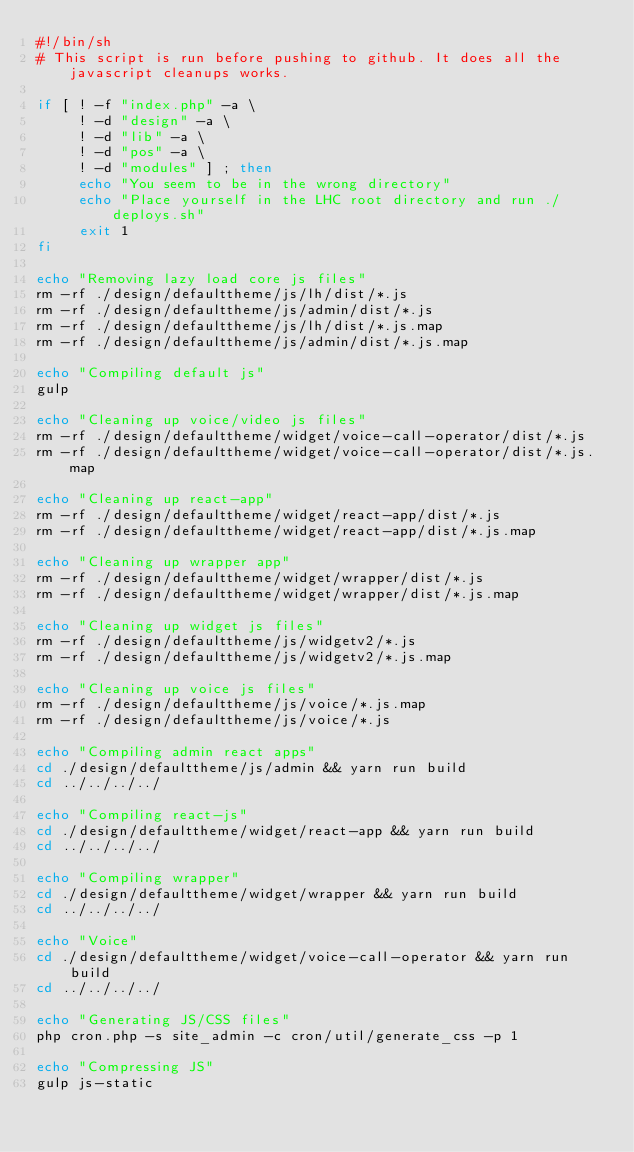Convert code to text. <code><loc_0><loc_0><loc_500><loc_500><_Bash_>#!/bin/sh
# This script is run before pushing to github. It does all the javascript cleanups works.

if [ ! -f "index.php" -a \
     ! -d "design" -a \
     ! -d "lib" -a \
     ! -d "pos" -a \
     ! -d "modules" ] ; then
     echo "You seem to be in the wrong directory"
     echo "Place yourself in the LHC root directory and run ./deploys.sh"
     exit 1
fi

echo "Removing lazy load core js files"
rm -rf ./design/defaulttheme/js/lh/dist/*.js
rm -rf ./design/defaulttheme/js/admin/dist/*.js
rm -rf ./design/defaulttheme/js/lh/dist/*.js.map
rm -rf ./design/defaulttheme/js/admin/dist/*.js.map

echo "Compiling default js"
gulp

echo "Cleaning up voice/video js files"
rm -rf ./design/defaulttheme/widget/voice-call-operator/dist/*.js
rm -rf ./design/defaulttheme/widget/voice-call-operator/dist/*.js.map

echo "Cleaning up react-app"
rm -rf ./design/defaulttheme/widget/react-app/dist/*.js
rm -rf ./design/defaulttheme/widget/react-app/dist/*.js.map

echo "Cleaning up wrapper app"
rm -rf ./design/defaulttheme/widget/wrapper/dist/*.js
rm -rf ./design/defaulttheme/widget/wrapper/dist/*.js.map

echo "Cleaning up widget js files"
rm -rf ./design/defaulttheme/js/widgetv2/*.js
rm -rf ./design/defaulttheme/js/widgetv2/*.js.map

echo "Cleaning up voice js files"
rm -rf ./design/defaulttheme/js/voice/*.js.map
rm -rf ./design/defaulttheme/js/voice/*.js

echo "Compiling admin react apps"
cd ./design/defaulttheme/js/admin && yarn run build
cd ../../../../

echo "Compiling react-js"
cd ./design/defaulttheme/widget/react-app && yarn run build
cd ../../../../

echo "Compiling wrapper"
cd ./design/defaulttheme/widget/wrapper && yarn run build
cd ../../../../

echo "Voice"
cd ./design/defaulttheme/widget/voice-call-operator && yarn run build
cd ../../../../

echo "Generating JS/CSS files"
php cron.php -s site_admin -c cron/util/generate_css -p 1

echo "Compressing JS"
gulp js-static</code> 